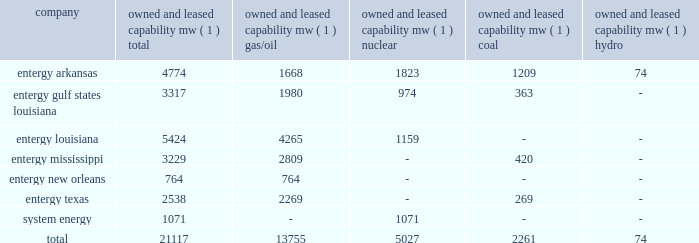Part i item 1 entergy corporation , utility operating companies , and system energy entergy new orleans provides electric and gas service in the city of new orleans pursuant to indeterminate permits set forth in city ordinances ( except electric service in algiers , which is provided by entergy louisiana ) .
These ordinances contain a continuing option for the city of new orleans to purchase entergy new orleans 2019s electric and gas utility properties .
Entergy texas holds a certificate of convenience and necessity from the puct to provide electric service to areas within approximately 27 counties in eastern texas , and holds non-exclusive franchises to provide electric service in approximately 68 incorporated municipalities .
Entergy texas was typically granted 50-year franchises , but recently has been receiving 25-year franchises .
Entergy texas 2019s electric franchises expire during 2013-2058 .
The business of system energy is limited to wholesale power sales .
It has no distribution franchises .
Property and other generation resources generating stations the total capability of the generating stations owned and leased by the utility operating companies and system energy as of december 31 , 2011 , is indicated below: .
( 1 ) 201cowned and leased capability 201d is the dependable load carrying capability as demonstrated under actual operating conditions based on the primary fuel ( assuming no curtailments ) that each station was designed to utilize .
The entergy system's load and capacity projections are reviewed periodically to assess the need and timing for additional generating capacity and interconnections .
These reviews consider existing and projected demand , the availability and price of power , the location of new load , and the economy .
Summer peak load in the entergy system service territory has averaged 21246 mw from 2002-2011 .
In the 2002 time period , the entergy system's long-term capacity resources , allowing for an adequate reserve margin , were approximately 3000 mw less than the total capacity required for peak period demands .
In this time period the entergy system met its capacity shortages almost entirely through short-term power purchases in the wholesale spot market .
In the fall of 2002 , the entergy system began a program to add new resources to its existing generation portfolio and began a process of issuing requests for proposals ( rfp ) to procure supply-side resources from sources other than the spot market to meet the unique regional needs of the utility operating companies .
The entergy system has adopted a long-term resource strategy that calls for the bulk of capacity needs to be met through long-term resources , whether owned or contracted .
Entergy refers to this strategy as the "portfolio transformation strategy" .
Over the past nine years , portfolio transformation has resulted in the addition of about 4500 mw of new long-term resources .
These figures do not include transactions currently pending as a result of the summer 2009 rfp .
When the summer 2009 rfp transactions are included in the entergy system portfolio of long-term resources and adjusting for unit deactivations of older generation , the entergy system is approximately 500 mw short of its projected 2012 peak load plus reserve margin .
This remaining need is expected to be met through a nuclear uprate at grand gulf and limited-term resources .
The entergy system will continue to access the spot power market to economically .
In 2011 what was the percent of the entergy arkansas property and other generation resources generating capacity that was from coal? 
Computations: (1209 / 4774)
Answer: 0.25325. 